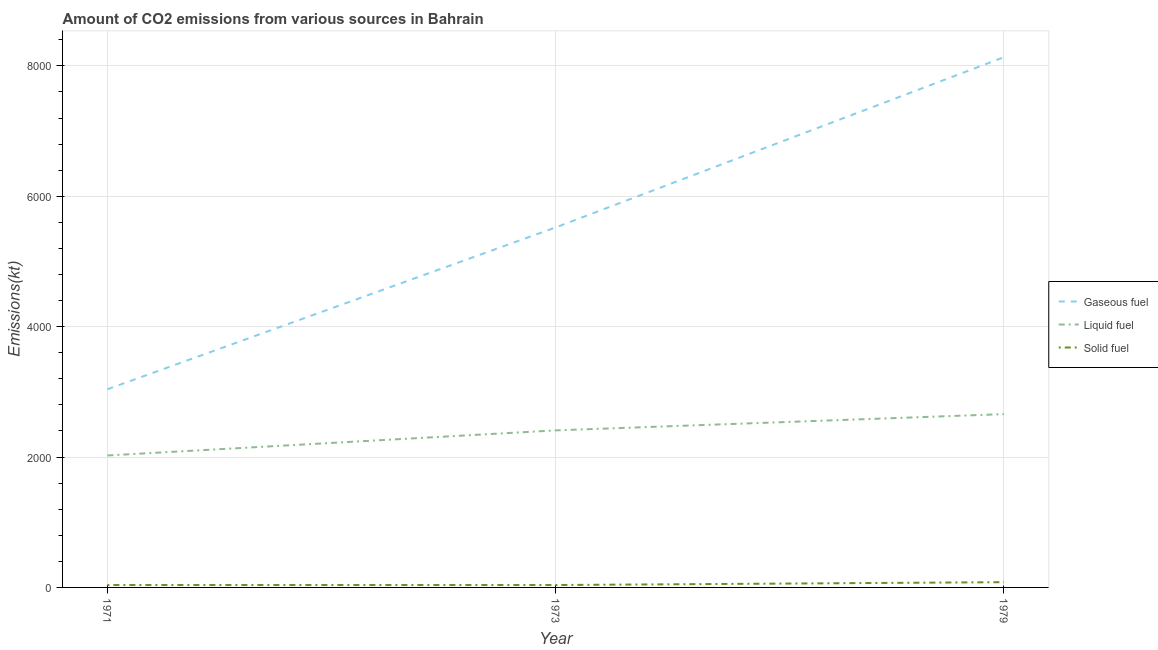Is the number of lines equal to the number of legend labels?
Your answer should be compact. Yes. What is the amount of co2 emissions from liquid fuel in 1973?
Your answer should be compact. 2409.22. Across all years, what is the maximum amount of co2 emissions from liquid fuel?
Your response must be concise. 2658.57. Across all years, what is the minimum amount of co2 emissions from liquid fuel?
Provide a succinct answer. 2024.18. In which year was the amount of co2 emissions from solid fuel maximum?
Your answer should be compact. 1979. In which year was the amount of co2 emissions from liquid fuel minimum?
Offer a very short reply. 1971. What is the total amount of co2 emissions from gaseous fuel in the graph?
Provide a short and direct response. 1.67e+04. What is the difference between the amount of co2 emissions from liquid fuel in 1971 and that in 1979?
Keep it short and to the point. -634.39. What is the difference between the amount of co2 emissions from gaseous fuel in 1971 and the amount of co2 emissions from liquid fuel in 1973?
Offer a very short reply. 630.72. What is the average amount of co2 emissions from solid fuel per year?
Your response must be concise. 51.34. In the year 1971, what is the difference between the amount of co2 emissions from liquid fuel and amount of co2 emissions from gaseous fuel?
Provide a short and direct response. -1015.76. What is the ratio of the amount of co2 emissions from solid fuel in 1971 to that in 1979?
Your answer should be compact. 0.45. Is the amount of co2 emissions from solid fuel in 1973 less than that in 1979?
Offer a very short reply. Yes. What is the difference between the highest and the second highest amount of co2 emissions from liquid fuel?
Ensure brevity in your answer.  249.36. What is the difference between the highest and the lowest amount of co2 emissions from gaseous fuel?
Ensure brevity in your answer.  5093.46. In how many years, is the amount of co2 emissions from liquid fuel greater than the average amount of co2 emissions from liquid fuel taken over all years?
Your answer should be compact. 2. Is the sum of the amount of co2 emissions from liquid fuel in 1973 and 1979 greater than the maximum amount of co2 emissions from gaseous fuel across all years?
Offer a very short reply. No. Is the amount of co2 emissions from gaseous fuel strictly greater than the amount of co2 emissions from liquid fuel over the years?
Your response must be concise. Yes. How many years are there in the graph?
Offer a terse response. 3. What is the difference between two consecutive major ticks on the Y-axis?
Your answer should be very brief. 2000. Are the values on the major ticks of Y-axis written in scientific E-notation?
Make the answer very short. No. Does the graph contain any zero values?
Keep it short and to the point. No. Where does the legend appear in the graph?
Provide a succinct answer. Center right. How are the legend labels stacked?
Offer a very short reply. Vertical. What is the title of the graph?
Make the answer very short. Amount of CO2 emissions from various sources in Bahrain. Does "Unemployment benefits" appear as one of the legend labels in the graph?
Your response must be concise. No. What is the label or title of the X-axis?
Give a very brief answer. Year. What is the label or title of the Y-axis?
Keep it short and to the point. Emissions(kt). What is the Emissions(kt) of Gaseous fuel in 1971?
Keep it short and to the point. 3039.94. What is the Emissions(kt) of Liquid fuel in 1971?
Keep it short and to the point. 2024.18. What is the Emissions(kt) in Solid fuel in 1971?
Provide a short and direct response. 36.67. What is the Emissions(kt) of Gaseous fuel in 1973?
Provide a succinct answer. 5522.5. What is the Emissions(kt) of Liquid fuel in 1973?
Offer a very short reply. 2409.22. What is the Emissions(kt) in Solid fuel in 1973?
Make the answer very short. 36.67. What is the Emissions(kt) of Gaseous fuel in 1979?
Offer a very short reply. 8133.41. What is the Emissions(kt) of Liquid fuel in 1979?
Your answer should be very brief. 2658.57. What is the Emissions(kt) of Solid fuel in 1979?
Give a very brief answer. 80.67. Across all years, what is the maximum Emissions(kt) of Gaseous fuel?
Offer a terse response. 8133.41. Across all years, what is the maximum Emissions(kt) in Liquid fuel?
Your answer should be compact. 2658.57. Across all years, what is the maximum Emissions(kt) of Solid fuel?
Your answer should be very brief. 80.67. Across all years, what is the minimum Emissions(kt) of Gaseous fuel?
Your response must be concise. 3039.94. Across all years, what is the minimum Emissions(kt) of Liquid fuel?
Your response must be concise. 2024.18. Across all years, what is the minimum Emissions(kt) in Solid fuel?
Ensure brevity in your answer.  36.67. What is the total Emissions(kt) of Gaseous fuel in the graph?
Your answer should be very brief. 1.67e+04. What is the total Emissions(kt) of Liquid fuel in the graph?
Offer a terse response. 7091.98. What is the total Emissions(kt) of Solid fuel in the graph?
Your answer should be very brief. 154.01. What is the difference between the Emissions(kt) in Gaseous fuel in 1971 and that in 1973?
Provide a succinct answer. -2482.56. What is the difference between the Emissions(kt) of Liquid fuel in 1971 and that in 1973?
Make the answer very short. -385.04. What is the difference between the Emissions(kt) of Solid fuel in 1971 and that in 1973?
Make the answer very short. 0. What is the difference between the Emissions(kt) of Gaseous fuel in 1971 and that in 1979?
Offer a very short reply. -5093.46. What is the difference between the Emissions(kt) of Liquid fuel in 1971 and that in 1979?
Give a very brief answer. -634.39. What is the difference between the Emissions(kt) of Solid fuel in 1971 and that in 1979?
Ensure brevity in your answer.  -44. What is the difference between the Emissions(kt) in Gaseous fuel in 1973 and that in 1979?
Provide a short and direct response. -2610.9. What is the difference between the Emissions(kt) of Liquid fuel in 1973 and that in 1979?
Offer a terse response. -249.36. What is the difference between the Emissions(kt) in Solid fuel in 1973 and that in 1979?
Your answer should be compact. -44. What is the difference between the Emissions(kt) of Gaseous fuel in 1971 and the Emissions(kt) of Liquid fuel in 1973?
Make the answer very short. 630.72. What is the difference between the Emissions(kt) of Gaseous fuel in 1971 and the Emissions(kt) of Solid fuel in 1973?
Provide a short and direct response. 3003.27. What is the difference between the Emissions(kt) of Liquid fuel in 1971 and the Emissions(kt) of Solid fuel in 1973?
Your answer should be very brief. 1987.51. What is the difference between the Emissions(kt) in Gaseous fuel in 1971 and the Emissions(kt) in Liquid fuel in 1979?
Provide a short and direct response. 381.37. What is the difference between the Emissions(kt) in Gaseous fuel in 1971 and the Emissions(kt) in Solid fuel in 1979?
Offer a very short reply. 2959.27. What is the difference between the Emissions(kt) of Liquid fuel in 1971 and the Emissions(kt) of Solid fuel in 1979?
Your answer should be very brief. 1943.51. What is the difference between the Emissions(kt) in Gaseous fuel in 1973 and the Emissions(kt) in Liquid fuel in 1979?
Give a very brief answer. 2863.93. What is the difference between the Emissions(kt) of Gaseous fuel in 1973 and the Emissions(kt) of Solid fuel in 1979?
Give a very brief answer. 5441.83. What is the difference between the Emissions(kt) of Liquid fuel in 1973 and the Emissions(kt) of Solid fuel in 1979?
Your response must be concise. 2328.55. What is the average Emissions(kt) in Gaseous fuel per year?
Your answer should be very brief. 5565.28. What is the average Emissions(kt) of Liquid fuel per year?
Your answer should be compact. 2363.99. What is the average Emissions(kt) in Solid fuel per year?
Keep it short and to the point. 51.34. In the year 1971, what is the difference between the Emissions(kt) in Gaseous fuel and Emissions(kt) in Liquid fuel?
Ensure brevity in your answer.  1015.76. In the year 1971, what is the difference between the Emissions(kt) of Gaseous fuel and Emissions(kt) of Solid fuel?
Your response must be concise. 3003.27. In the year 1971, what is the difference between the Emissions(kt) of Liquid fuel and Emissions(kt) of Solid fuel?
Offer a very short reply. 1987.51. In the year 1973, what is the difference between the Emissions(kt) in Gaseous fuel and Emissions(kt) in Liquid fuel?
Ensure brevity in your answer.  3113.28. In the year 1973, what is the difference between the Emissions(kt) of Gaseous fuel and Emissions(kt) of Solid fuel?
Provide a succinct answer. 5485.83. In the year 1973, what is the difference between the Emissions(kt) in Liquid fuel and Emissions(kt) in Solid fuel?
Provide a short and direct response. 2372.55. In the year 1979, what is the difference between the Emissions(kt) of Gaseous fuel and Emissions(kt) of Liquid fuel?
Offer a very short reply. 5474.83. In the year 1979, what is the difference between the Emissions(kt) of Gaseous fuel and Emissions(kt) of Solid fuel?
Offer a very short reply. 8052.73. In the year 1979, what is the difference between the Emissions(kt) of Liquid fuel and Emissions(kt) of Solid fuel?
Make the answer very short. 2577.9. What is the ratio of the Emissions(kt) of Gaseous fuel in 1971 to that in 1973?
Your answer should be compact. 0.55. What is the ratio of the Emissions(kt) in Liquid fuel in 1971 to that in 1973?
Keep it short and to the point. 0.84. What is the ratio of the Emissions(kt) of Solid fuel in 1971 to that in 1973?
Your response must be concise. 1. What is the ratio of the Emissions(kt) in Gaseous fuel in 1971 to that in 1979?
Your answer should be compact. 0.37. What is the ratio of the Emissions(kt) in Liquid fuel in 1971 to that in 1979?
Offer a terse response. 0.76. What is the ratio of the Emissions(kt) of Solid fuel in 1971 to that in 1979?
Give a very brief answer. 0.45. What is the ratio of the Emissions(kt) in Gaseous fuel in 1973 to that in 1979?
Your answer should be very brief. 0.68. What is the ratio of the Emissions(kt) of Liquid fuel in 1973 to that in 1979?
Give a very brief answer. 0.91. What is the ratio of the Emissions(kt) of Solid fuel in 1973 to that in 1979?
Give a very brief answer. 0.45. What is the difference between the highest and the second highest Emissions(kt) of Gaseous fuel?
Keep it short and to the point. 2610.9. What is the difference between the highest and the second highest Emissions(kt) of Liquid fuel?
Ensure brevity in your answer.  249.36. What is the difference between the highest and the second highest Emissions(kt) of Solid fuel?
Your answer should be very brief. 44. What is the difference between the highest and the lowest Emissions(kt) of Gaseous fuel?
Provide a succinct answer. 5093.46. What is the difference between the highest and the lowest Emissions(kt) of Liquid fuel?
Provide a short and direct response. 634.39. What is the difference between the highest and the lowest Emissions(kt) in Solid fuel?
Offer a very short reply. 44. 